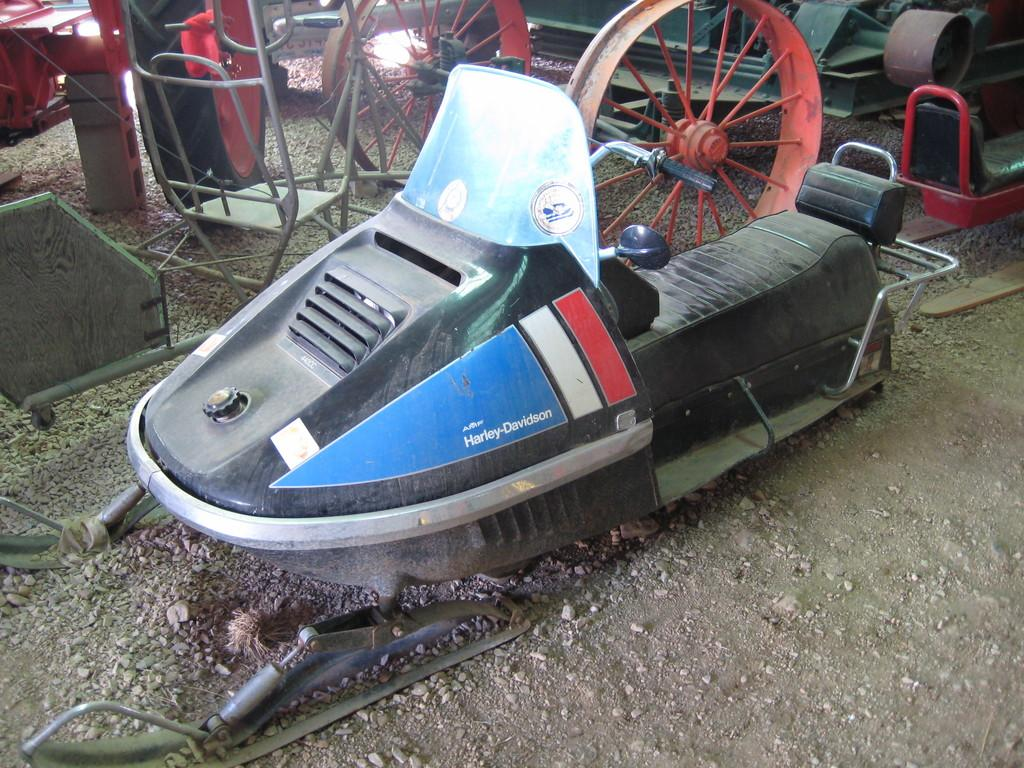What type of vehicle is the main subject of the image? There is a snowmobile in the image. Can you identify the brand of the snowmobile? The snowmobile is labeled as Harley Davidson. Are there any other vehicles visible in the image? Yes, there are other vehicles visible in the image. What type of clam is being used as a hobby in the image? There are no clams or hobbies present in the image; it features a snowmobile and other vehicles. 